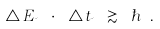Convert formula to latex. <formula><loc_0><loc_0><loc_500><loc_500>\triangle \, E _ { \psi } \ \cdot \ \triangle t _ { \psi } \ \gtrsim \ \hbar { \ } .</formula> 